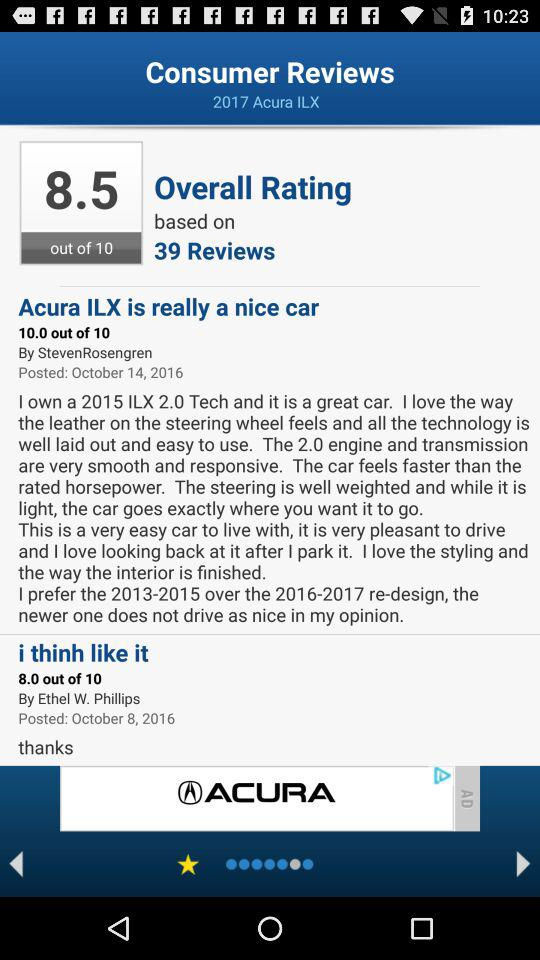On which date did Ethel W. Phillips review the "2017 Acura ILX"? Ethel W. Phillips reviewed the "2017 Acura ILX" on October 8, 2016. 